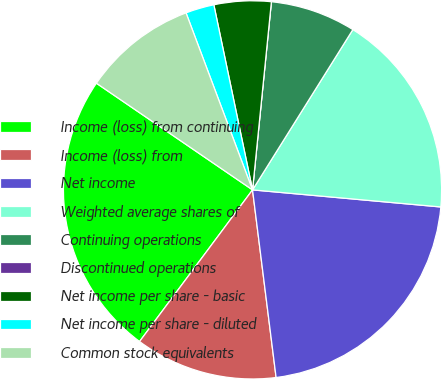Convert chart to OTSL. <chart><loc_0><loc_0><loc_500><loc_500><pie_chart><fcel>Income (loss) from continuing<fcel>Income (loss) from<fcel>Net income<fcel>Weighted average shares of<fcel>Continuing operations<fcel>Discontinued operations<fcel>Net income per share - basic<fcel>Net income per share - diluted<fcel>Common stock equivalents<nl><fcel>24.35%<fcel>12.18%<fcel>21.57%<fcel>17.54%<fcel>7.31%<fcel>0.0%<fcel>4.87%<fcel>2.44%<fcel>9.74%<nl></chart> 